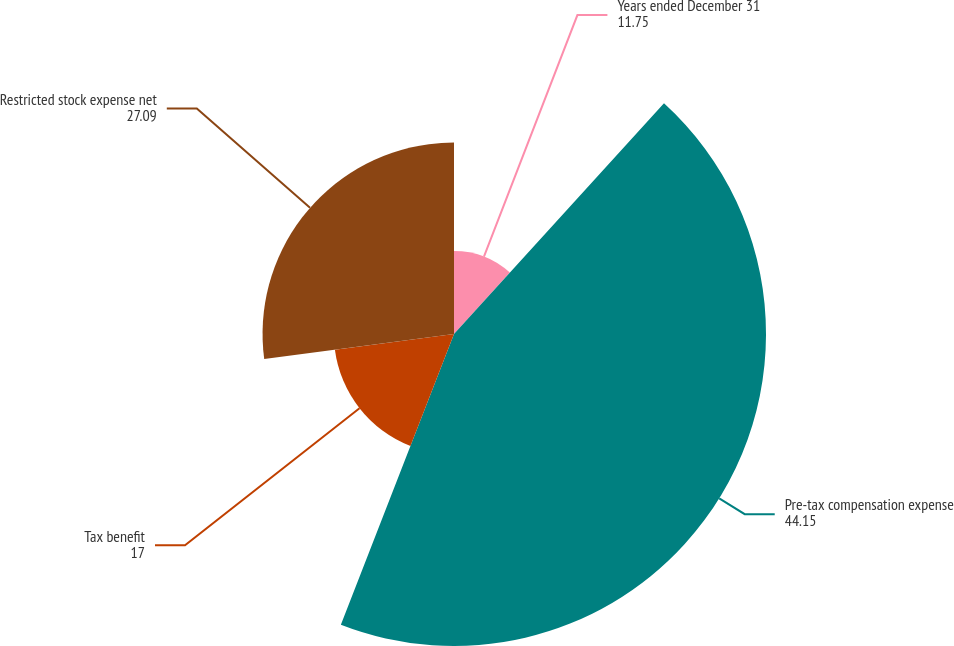Convert chart. <chart><loc_0><loc_0><loc_500><loc_500><pie_chart><fcel>Years ended December 31<fcel>Pre-tax compensation expense<fcel>Tax benefit<fcel>Restricted stock expense net<nl><fcel>11.75%<fcel>44.15%<fcel>17.0%<fcel>27.09%<nl></chart> 